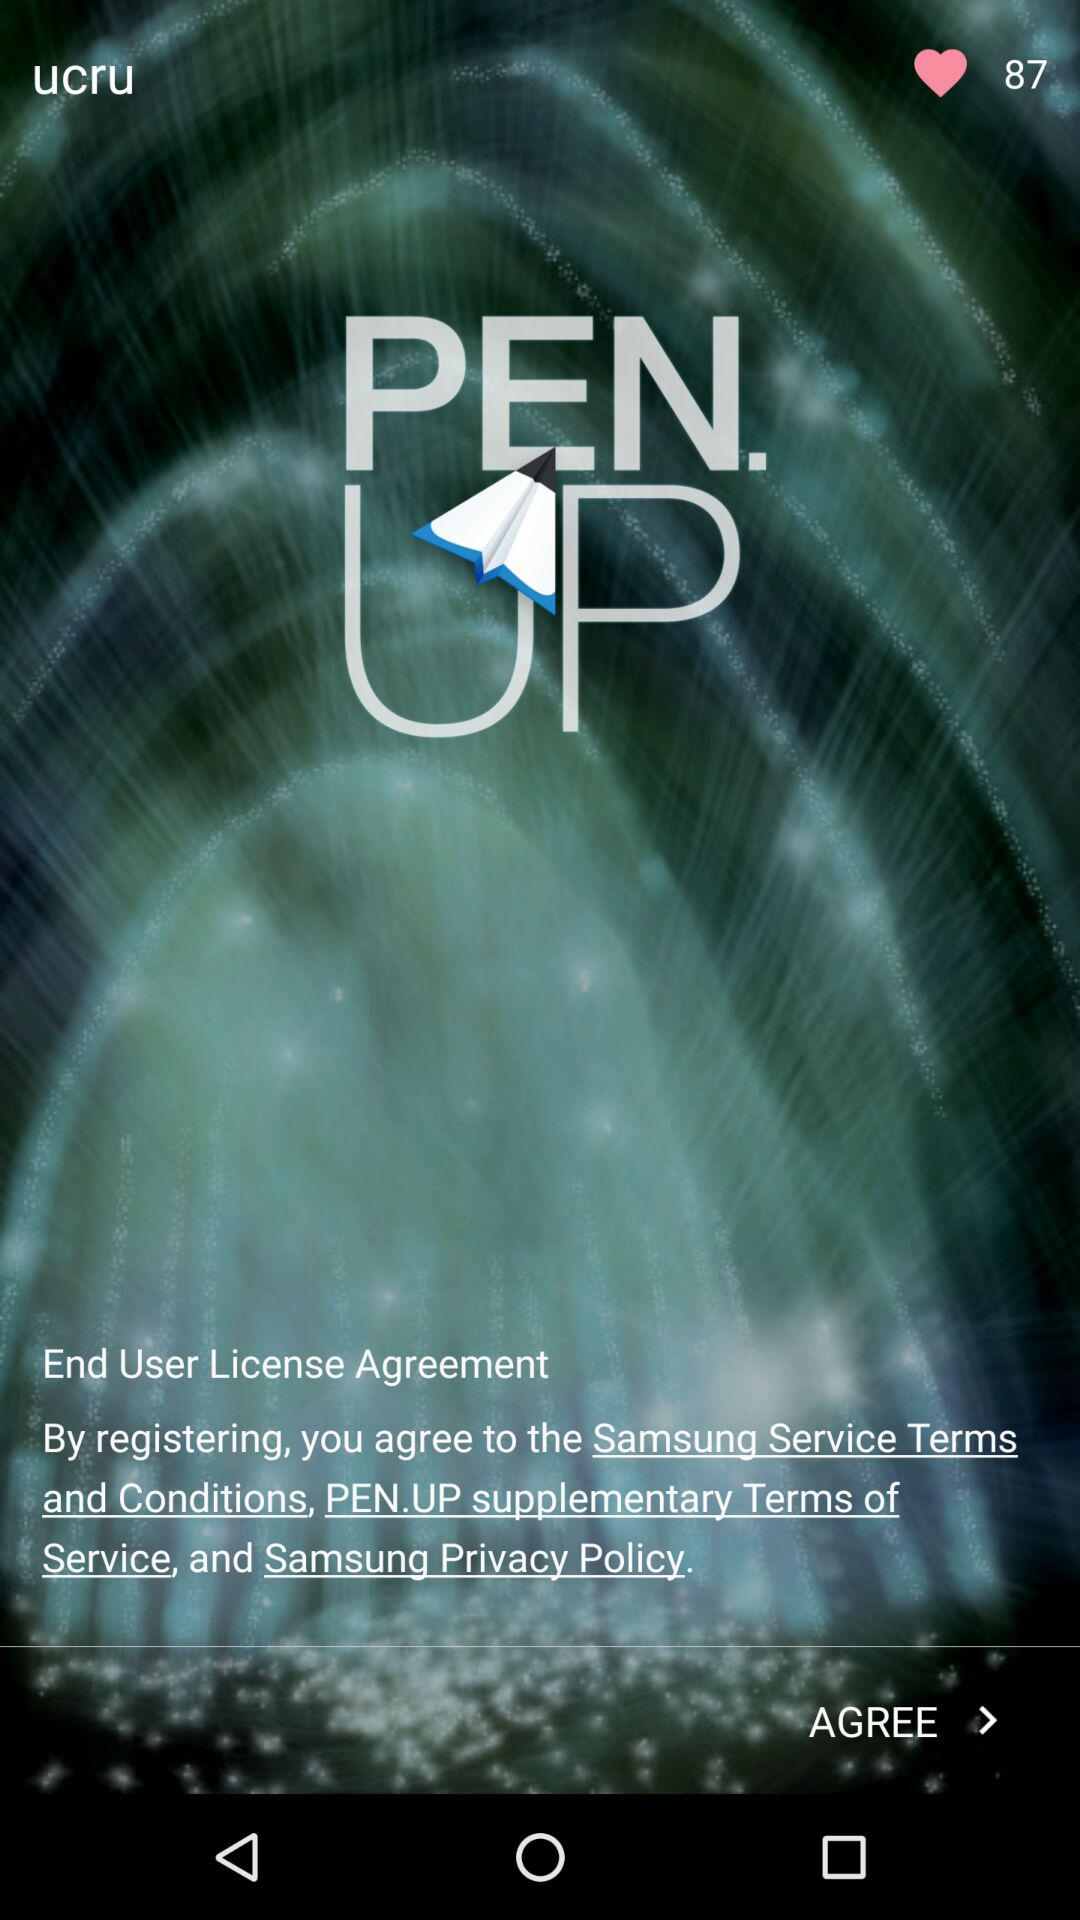How many likes are there? There are 87 likes. 